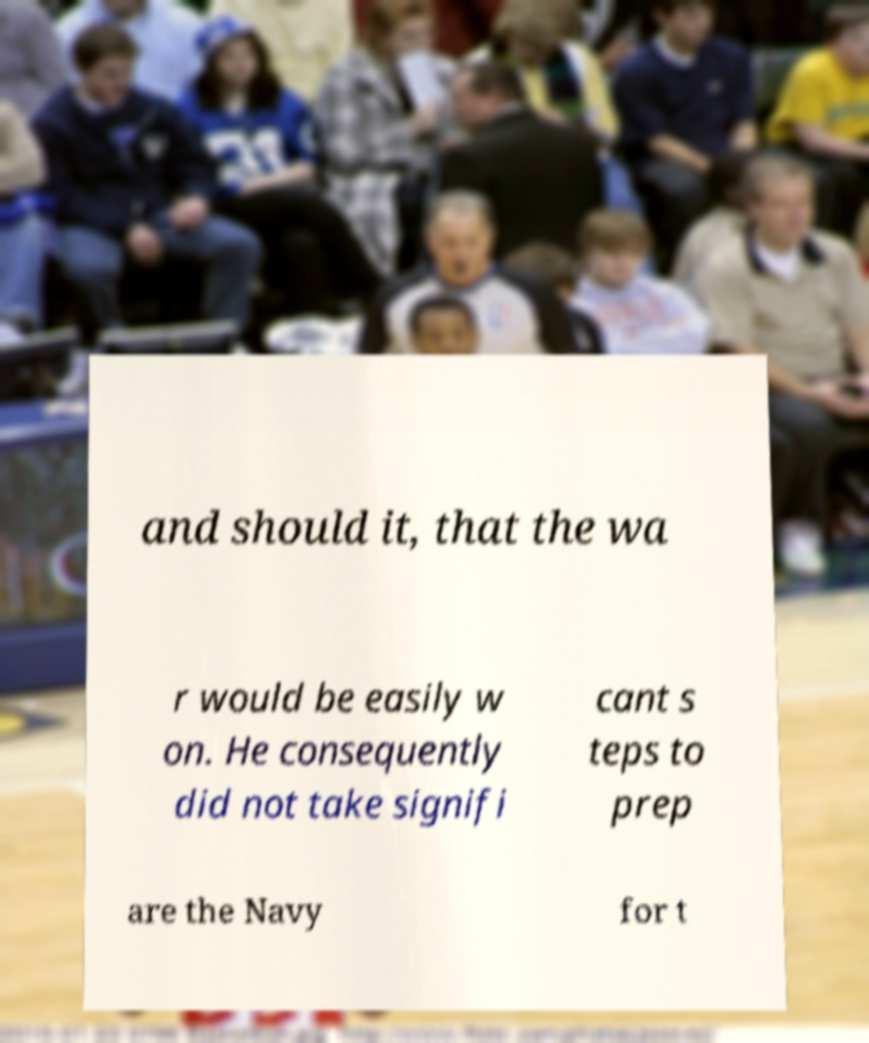Could you assist in decoding the text presented in this image and type it out clearly? and should it, that the wa r would be easily w on. He consequently did not take signifi cant s teps to prep are the Navy for t 